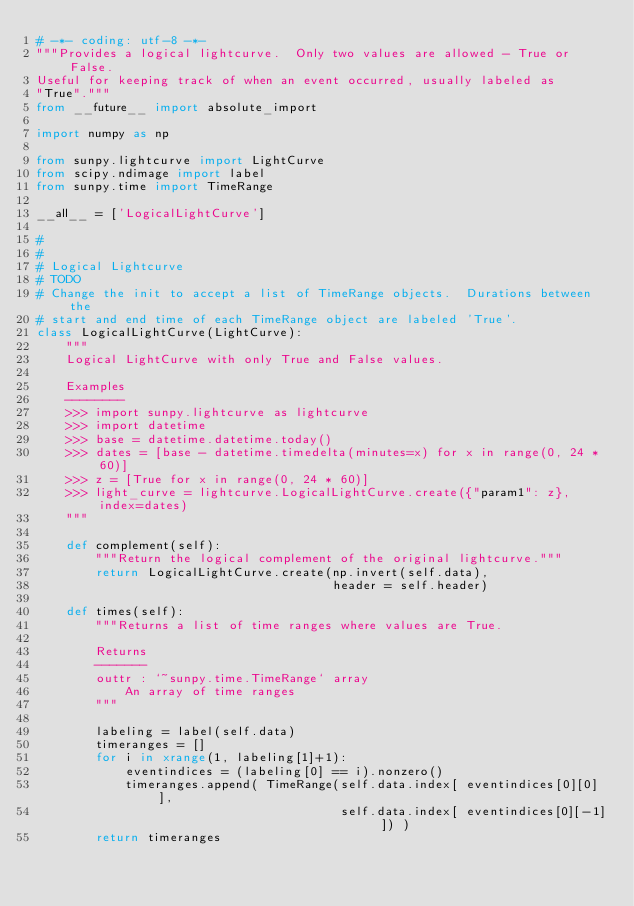<code> <loc_0><loc_0><loc_500><loc_500><_Python_># -*- coding: utf-8 -*-
"""Provides a logical lightcurve.  Only two values are allowed - True or False.
Useful for keeping track of when an event occurred, usually labeled as
"True"."""
from __future__ import absolute_import

import numpy as np

from sunpy.lightcurve import LightCurve
from scipy.ndimage import label
from sunpy.time import TimeRange

__all__ = ['LogicalLightCurve']

#
#
# Logical Lightcurve
# TODO
# Change the init to accept a list of TimeRange objects.  Durations between the
# start and end time of each TimeRange object are labeled 'True'.
class LogicalLightCurve(LightCurve):
    """
    Logical LightCurve with only True and False values.

    Examples
    --------
    >>> import sunpy.lightcurve as lightcurve
    >>> import datetime
    >>> base = datetime.datetime.today()
    >>> dates = [base - datetime.timedelta(minutes=x) for x in range(0, 24 * 60)]
    >>> z = [True for x in range(0, 24 * 60)]
    >>> light_curve = lightcurve.LogicalLightCurve.create({"param1": z}, index=dates)
    """

    def complement(self):
        """Return the logical complement of the original lightcurve."""
        return LogicalLightCurve.create(np.invert(self.data),
                                        header = self.header)

    def times(self):
        """Returns a list of time ranges where values are True.

        Returns
        -------
        outtr : `~sunpy.time.TimeRange` array
            An array of time ranges
        """

        labeling = label(self.data)
        timeranges = []
        for i in xrange(1, labeling[1]+1):
            eventindices = (labeling[0] == i).nonzero()
            timeranges.append( TimeRange(self.data.index[ eventindices[0][0] ],
                                         self.data.index[ eventindices[0][-1] ]) )
        return timeranges
</code> 